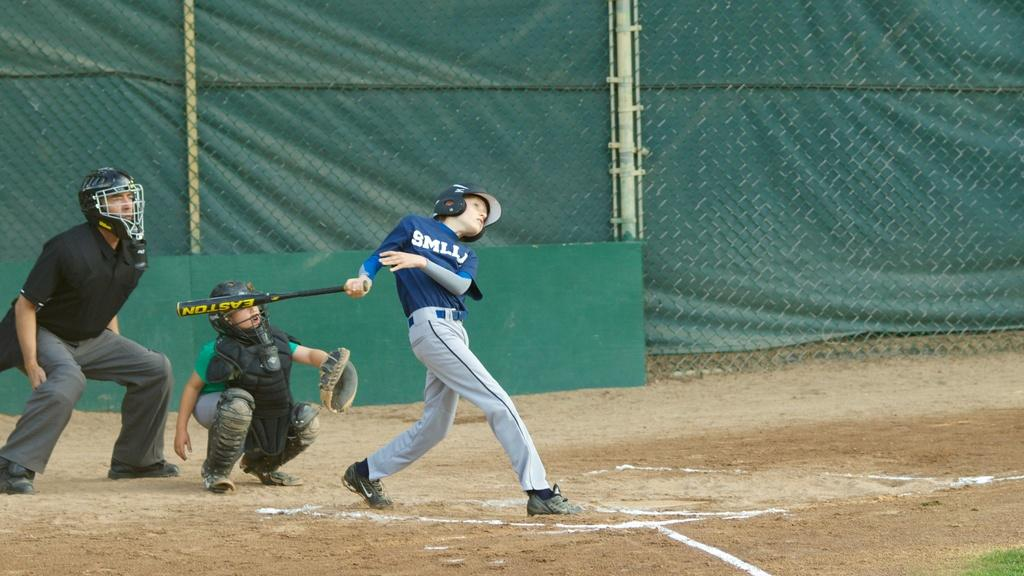Provide a one-sentence caption for the provided image. A young baseball player has just swung an Easton bat on a field. 